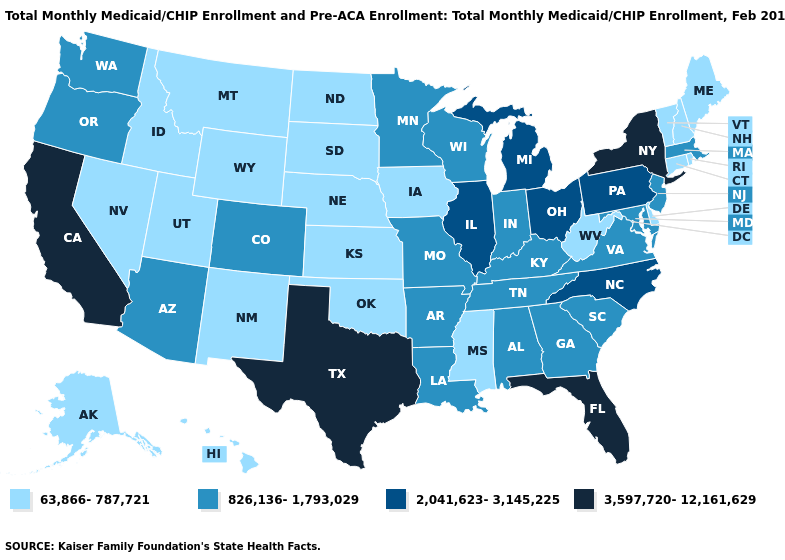What is the highest value in the MidWest ?
Short answer required. 2,041,623-3,145,225. What is the value of Georgia?
Concise answer only. 826,136-1,793,029. Does California have the highest value in the USA?
Quick response, please. Yes. Does Indiana have a higher value than New Jersey?
Answer briefly. No. Is the legend a continuous bar?
Give a very brief answer. No. Does Maine have the highest value in the USA?
Concise answer only. No. Name the states that have a value in the range 63,866-787,721?
Write a very short answer. Alaska, Connecticut, Delaware, Hawaii, Idaho, Iowa, Kansas, Maine, Mississippi, Montana, Nebraska, Nevada, New Hampshire, New Mexico, North Dakota, Oklahoma, Rhode Island, South Dakota, Utah, Vermont, West Virginia, Wyoming. What is the highest value in the Northeast ?
Give a very brief answer. 3,597,720-12,161,629. What is the lowest value in the USA?
Give a very brief answer. 63,866-787,721. Among the states that border Nebraska , does South Dakota have the highest value?
Keep it brief. No. Name the states that have a value in the range 826,136-1,793,029?
Write a very short answer. Alabama, Arizona, Arkansas, Colorado, Georgia, Indiana, Kentucky, Louisiana, Maryland, Massachusetts, Minnesota, Missouri, New Jersey, Oregon, South Carolina, Tennessee, Virginia, Washington, Wisconsin. Name the states that have a value in the range 3,597,720-12,161,629?
Write a very short answer. California, Florida, New York, Texas. What is the value of Nevada?
Write a very short answer. 63,866-787,721. Name the states that have a value in the range 2,041,623-3,145,225?
Be succinct. Illinois, Michigan, North Carolina, Ohio, Pennsylvania. Which states hav the highest value in the Northeast?
Write a very short answer. New York. 